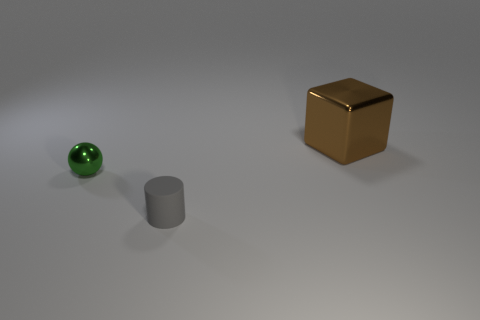Add 2 tiny cyan matte blocks. How many objects exist? 5 Subtract 0 yellow cylinders. How many objects are left? 3 Subtract all spheres. How many objects are left? 2 Subtract all brown balls. Subtract all red cubes. How many balls are left? 1 Subtract all big brown things. Subtract all large green metallic objects. How many objects are left? 2 Add 3 big cubes. How many big cubes are left? 4 Add 3 small rubber objects. How many small rubber objects exist? 4 